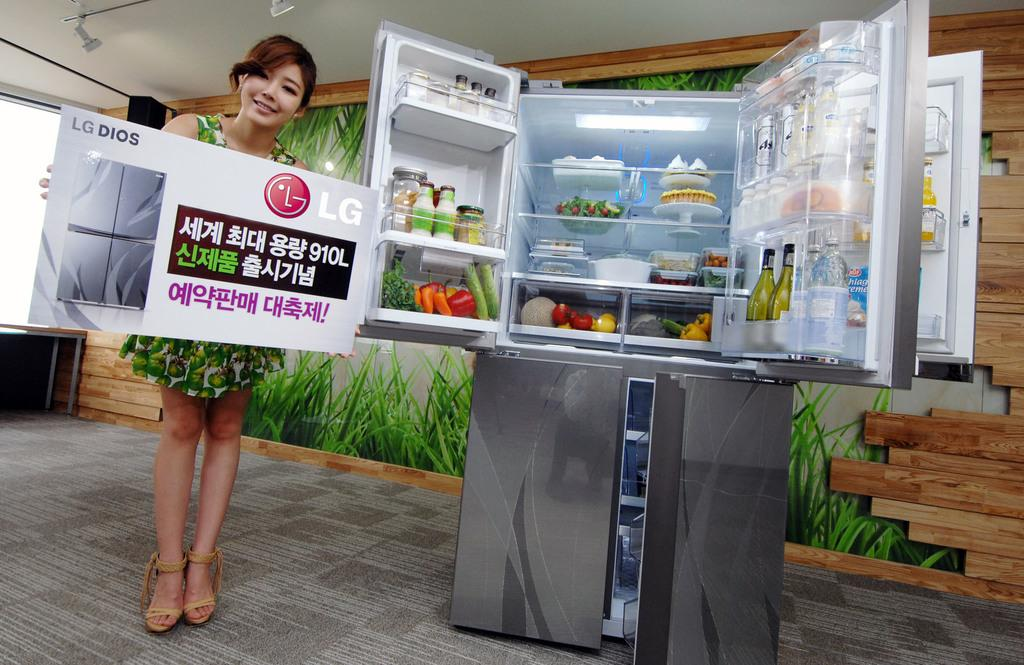<image>
Render a clear and concise summary of the photo. a girl is advertising the LG refrigerator that she is standing near 